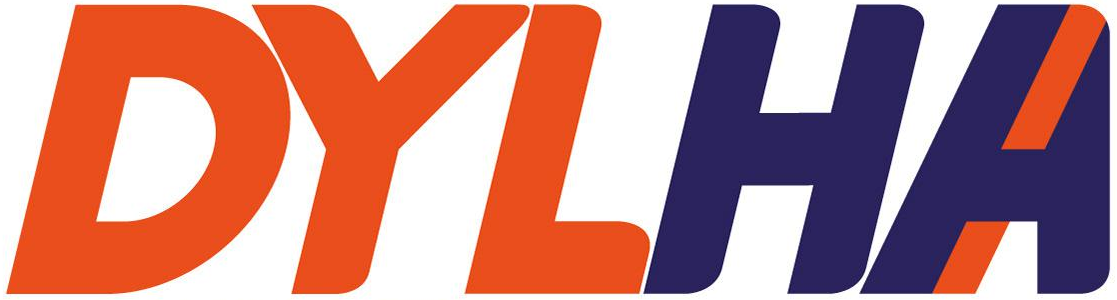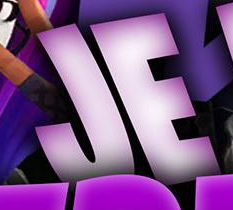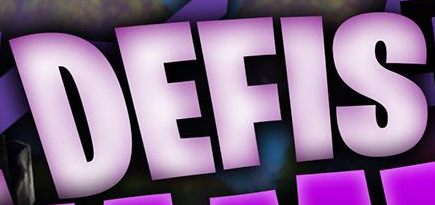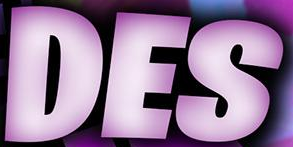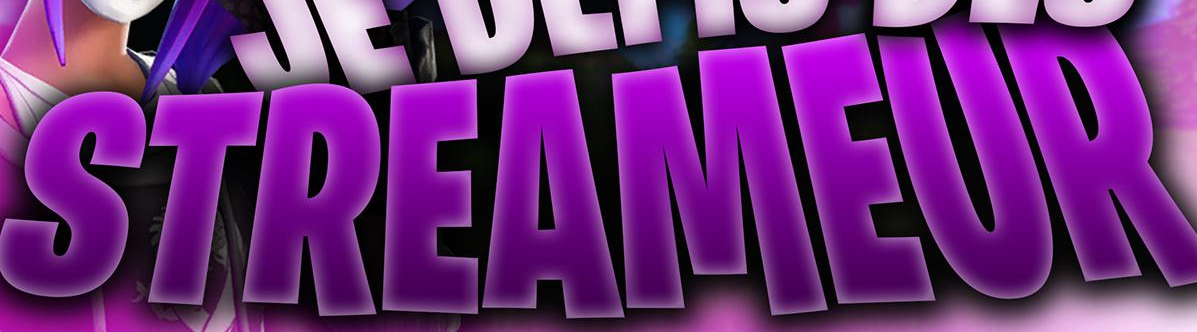What text appears in these images from left to right, separated by a semicolon? DYLHA; JE; DEFIS; DES; STREAMEUR 